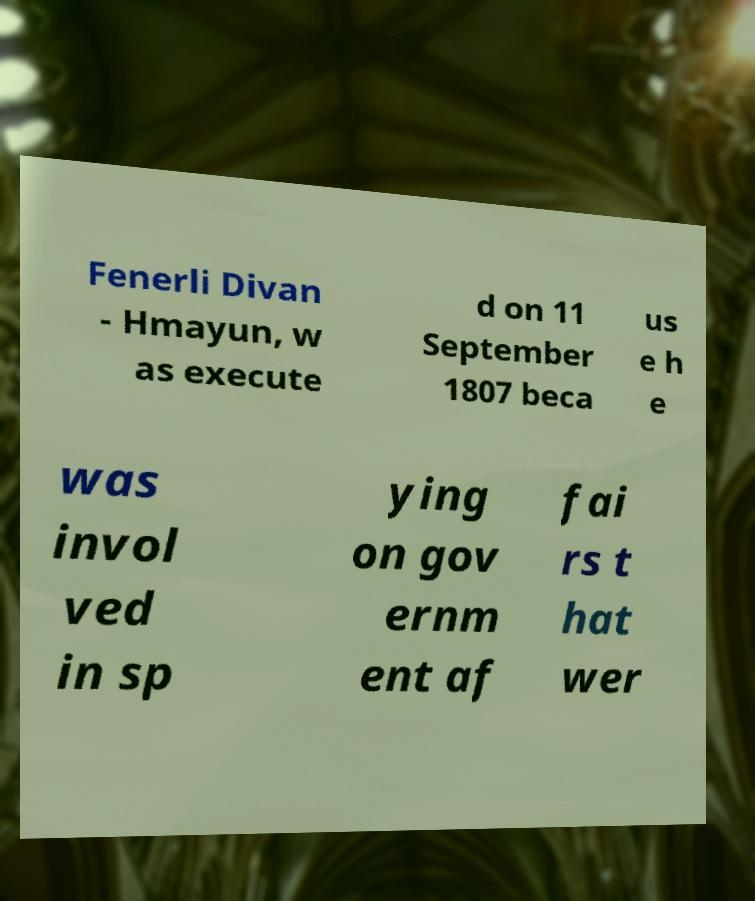Can you read and provide the text displayed in the image?This photo seems to have some interesting text. Can you extract and type it out for me? Fenerli Divan - Hmayun, w as execute d on 11 September 1807 beca us e h e was invol ved in sp ying on gov ernm ent af fai rs t hat wer 